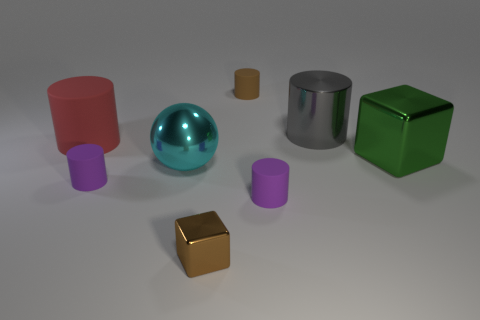Subtract 2 cylinders. How many cylinders are left? 3 Subtract all gray cylinders. How many cylinders are left? 4 Subtract all gray shiny cylinders. How many cylinders are left? 4 Subtract all cyan cylinders. Subtract all green blocks. How many cylinders are left? 5 Add 1 rubber things. How many objects exist? 9 Subtract all blocks. How many objects are left? 6 Subtract 1 green cubes. How many objects are left? 7 Subtract all red things. Subtract all big blue shiny things. How many objects are left? 7 Add 3 big gray things. How many big gray things are left? 4 Add 3 large metal cylinders. How many large metal cylinders exist? 4 